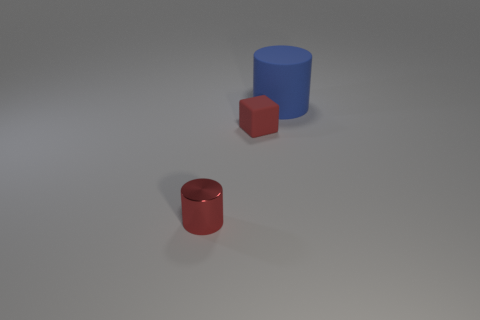Add 3 tiny brown cylinders. How many objects exist? 6 Subtract all cubes. How many objects are left? 2 Subtract 1 blue cylinders. How many objects are left? 2 Subtract all small red rubber things. Subtract all red matte cubes. How many objects are left? 1 Add 1 metallic objects. How many metallic objects are left? 2 Add 3 cyan metal cubes. How many cyan metal cubes exist? 3 